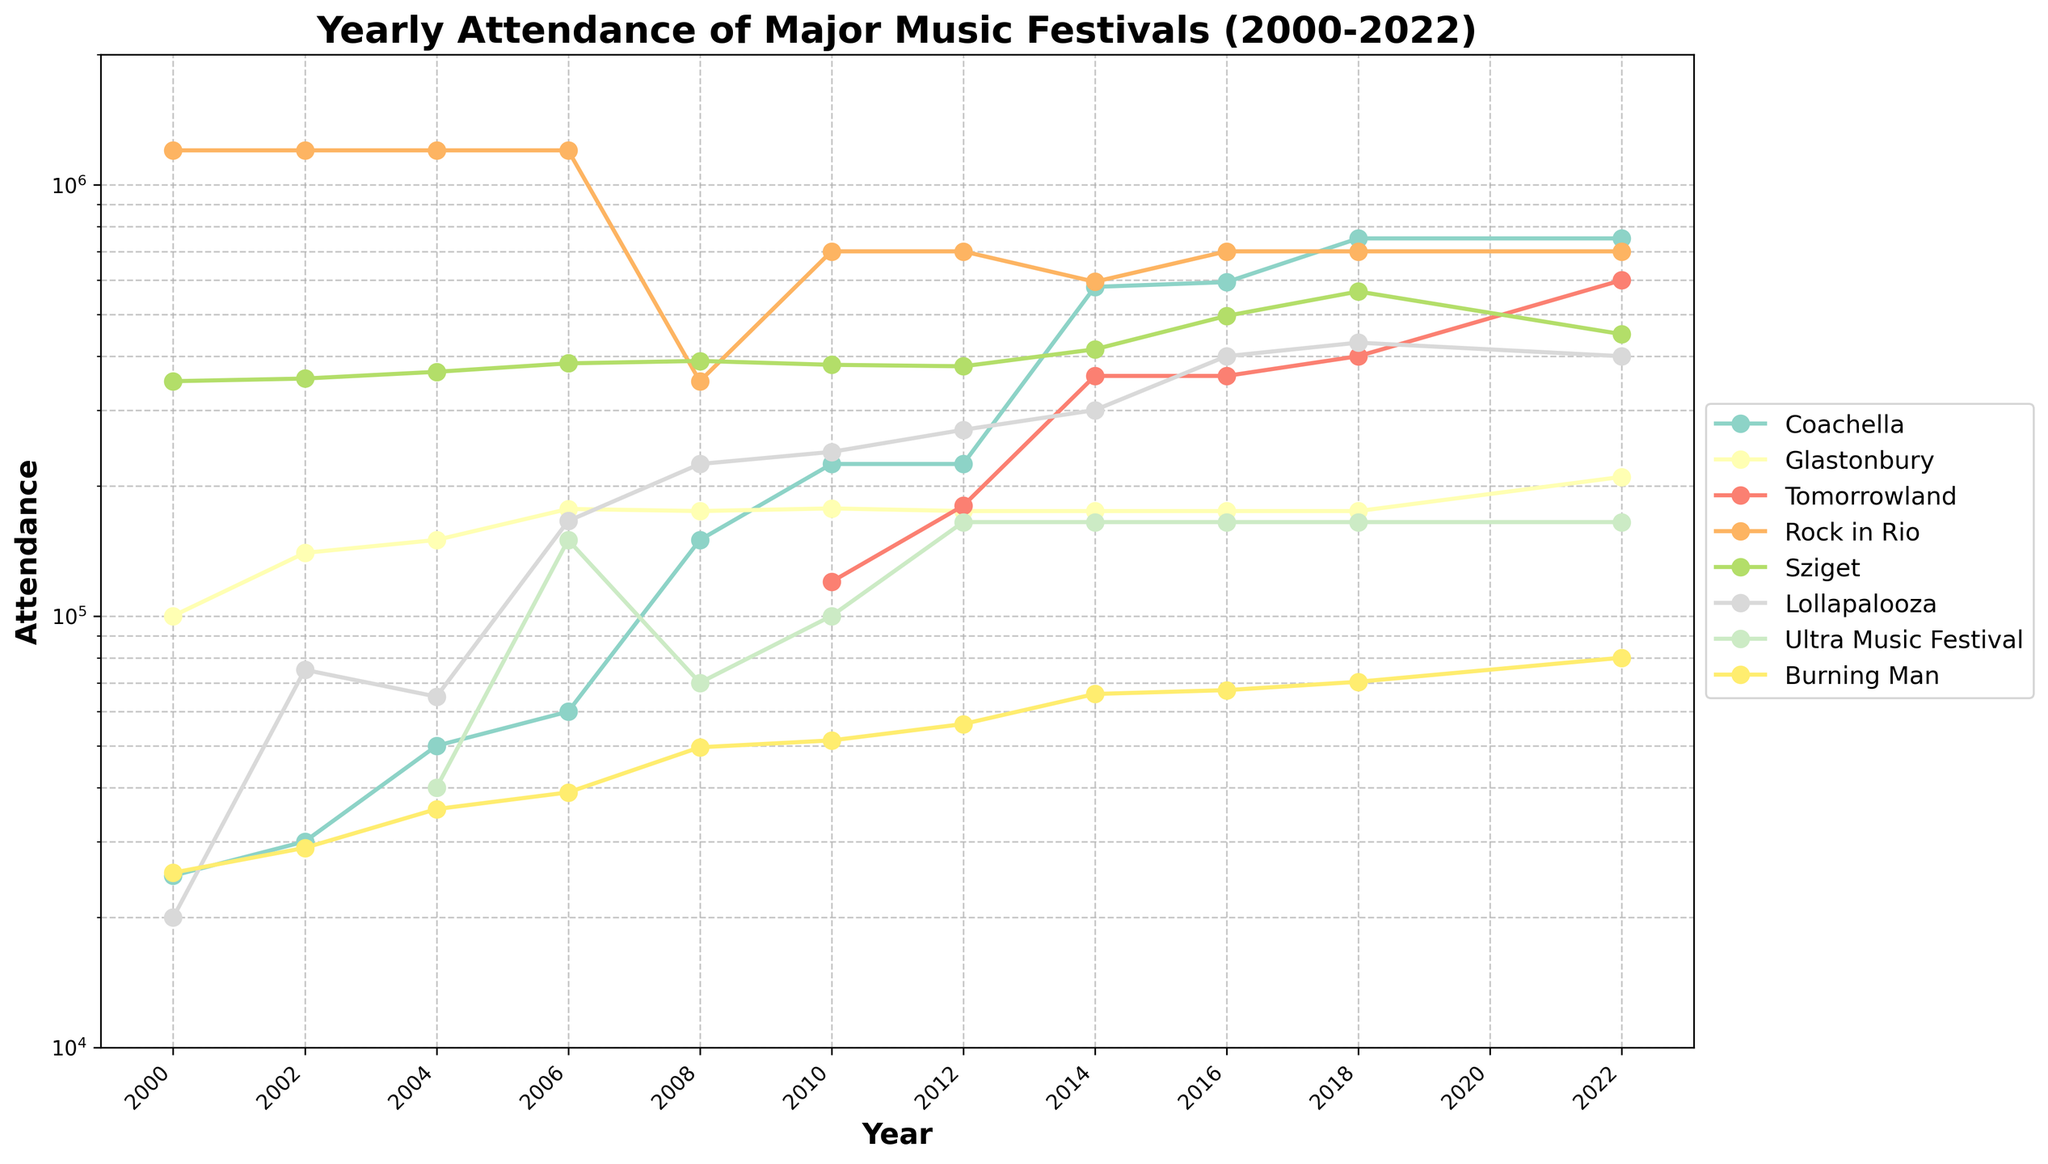What year did Coachella experience the largest increase in attendance? Coachella saw an increase from 60,000 in 2006 to 150,000 in 2008, which is an increase of 90,000. Looking at the plot, this is the largest increase between consecutive years.
Answer: 2008 Which festivals showed a continuous increase in attendance from 2008 to 2018? By examining the lines from 2008 to 2018, Coachella and Lollapalooza show a continuous upward trend throughout this period.
Answer: Coachella, Lollapalooza Which festival had the highest attendance in 2022 and what was the approximate attendance? The line representing Coachella peaks the highest in 2022. By referring to the y-axis, Coachella's attendance is approximately 750,000.
Answer: Coachella, 750,000 Did Glastonbury or Burning Man have more significant attendance growth from 2000 to 2022? Compare the initial and final attendance values: Glastonbury went from 100,000 to 210,000, an increase of 110,000. Burning Man increased from 25,400 to 80,000, an increase of 54,600.
Answer: Glastonbury Which festival experienced the steepest drop in attendance after 2018? Analyze the lines after 2018: Tomorrowland's line dramatically drops from 2018 to 2022. It decreased from around 400,000 to 200,000.
Answer: Tomorrowland What is the attendance range of Rock in Rio throughout the entire period? The highest attendance for Rock in Rio is 1,200,000 (2000-2008) and the lowest is 595,000 (2014), so the range is 1,200,000 - 595,000.
Answer: 605,000 Find the festival with the most stable attendance (least fluctuation) from 2000 to 2022. By observing the lines, Glastonbury’s attendance fluctuates the least around 140,000-210,000. The variance in its line is minimal compared to others.
Answer: Glastonbury Considering all festivals, which one showed the most consistent increase from 2000 to 2018? Looking at the steadily rising lines, Coachella shows a consistent increase in attendance from 25,000 in 2000 to 750,000 in 2018 without dropping.
Answer: Coachella 